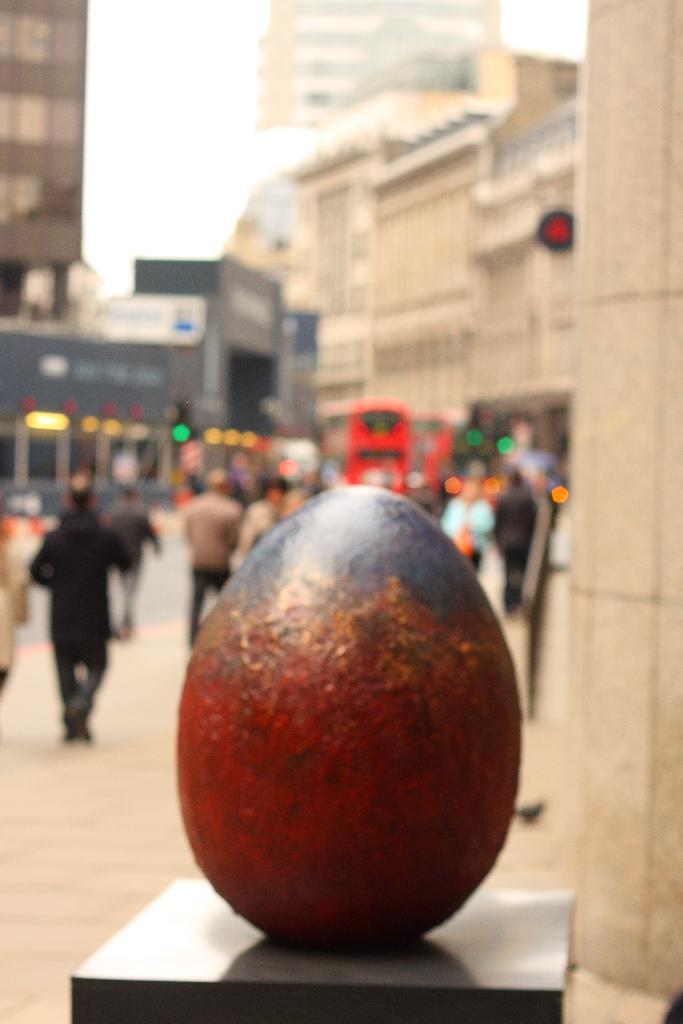Describe this image in one or two sentences. In this picture we can see an oval shaped object on the path and behind the object there are blurred people, bus, buildings, lights and the sky. 